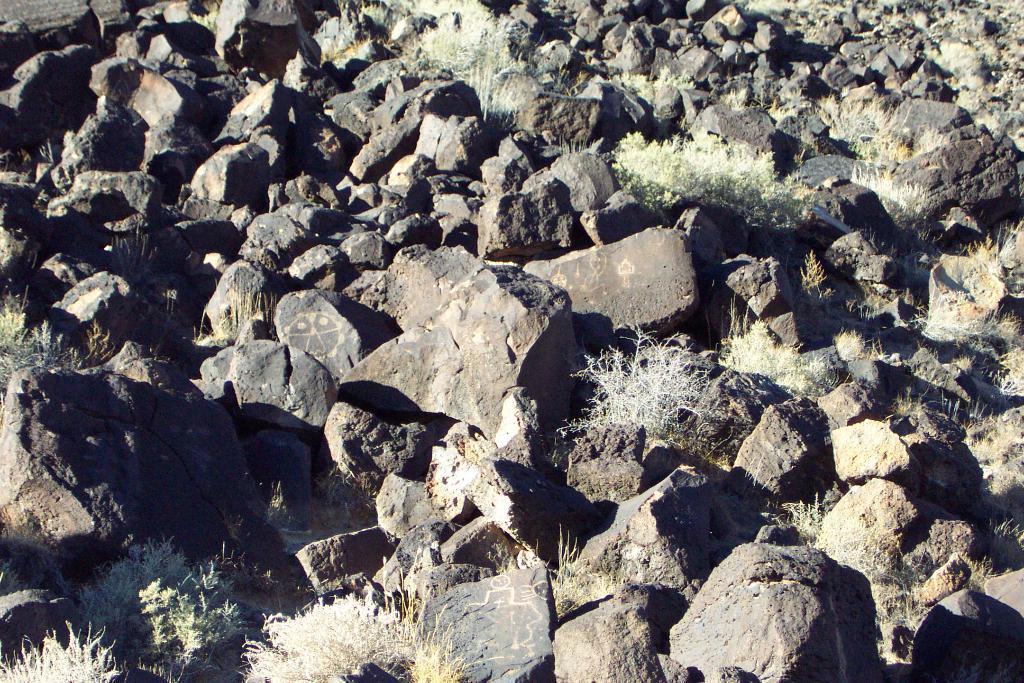Could you give a brief overview of what you see in this image? In this picture i can see rocks and plants. 